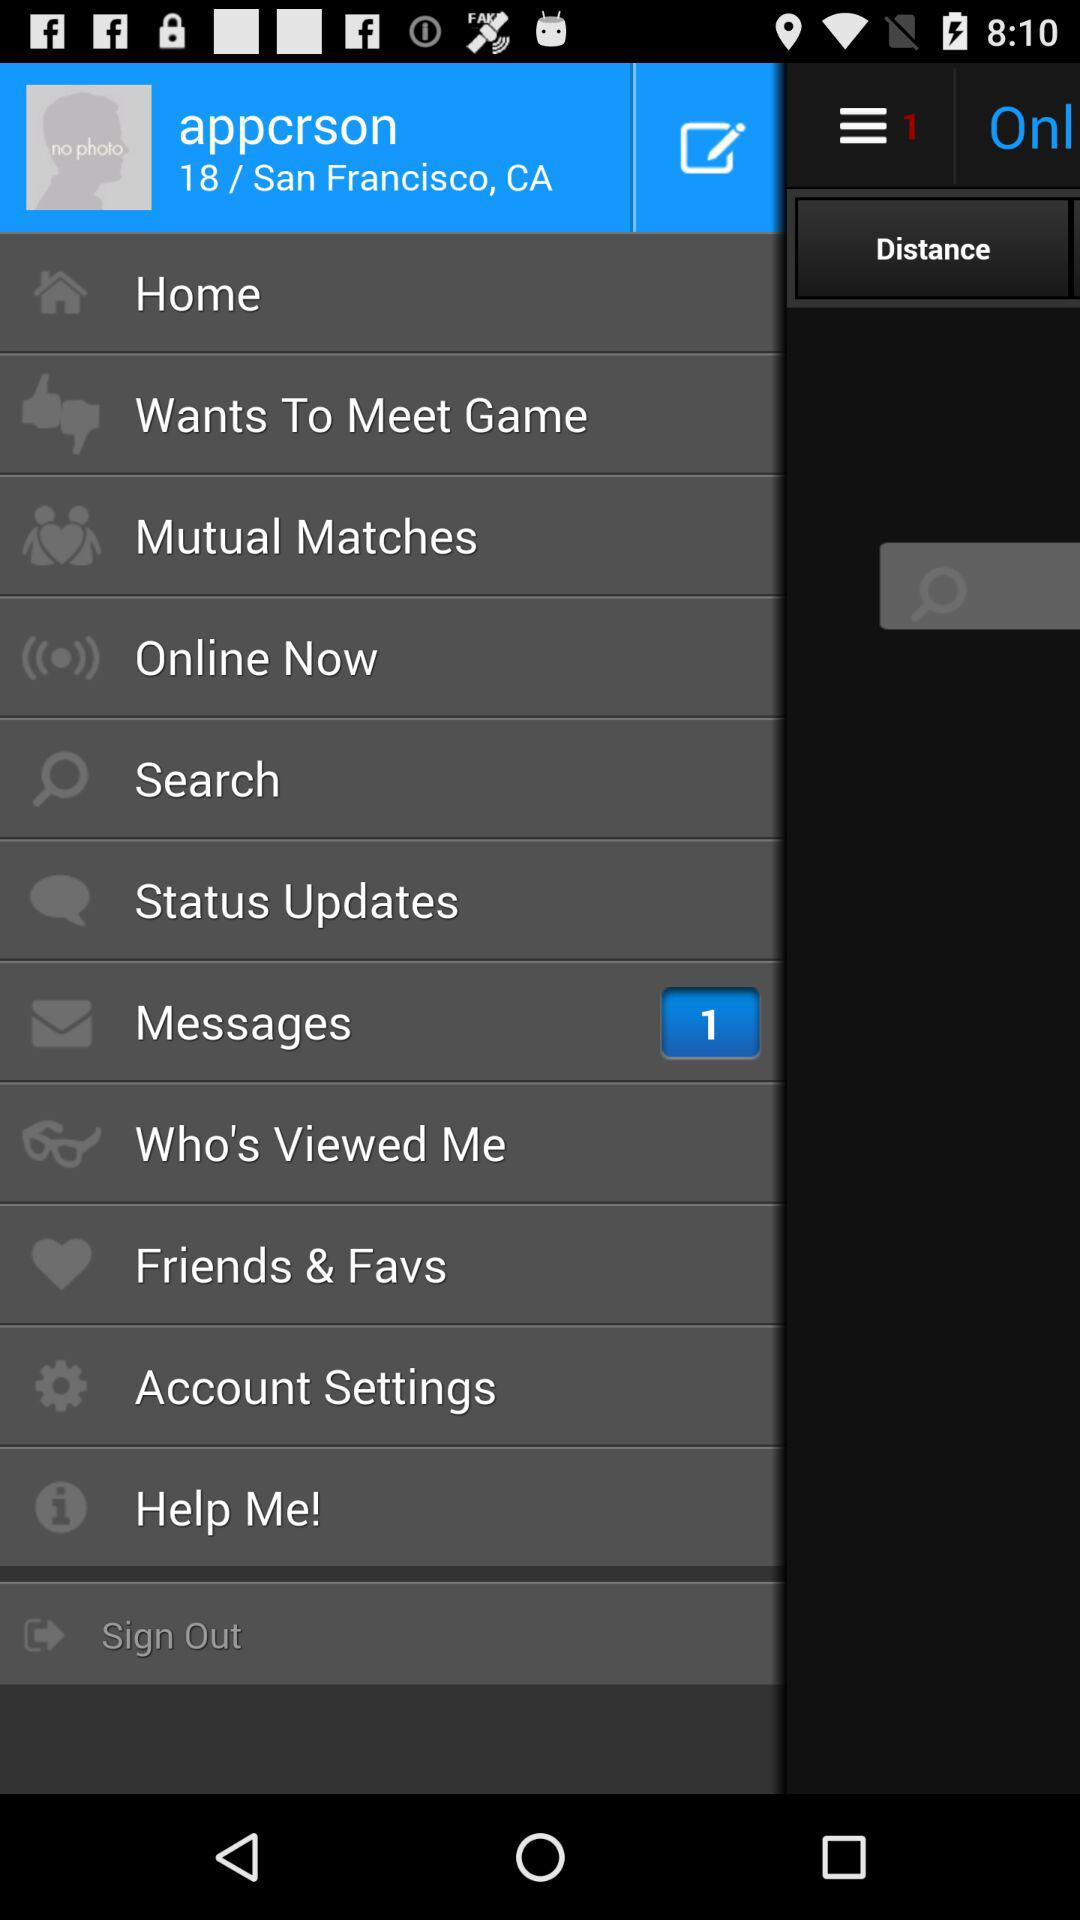What is the login name? The login name is "appcrson". 